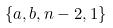<formula> <loc_0><loc_0><loc_500><loc_500>\{ a , b , n - 2 , 1 \}</formula> 